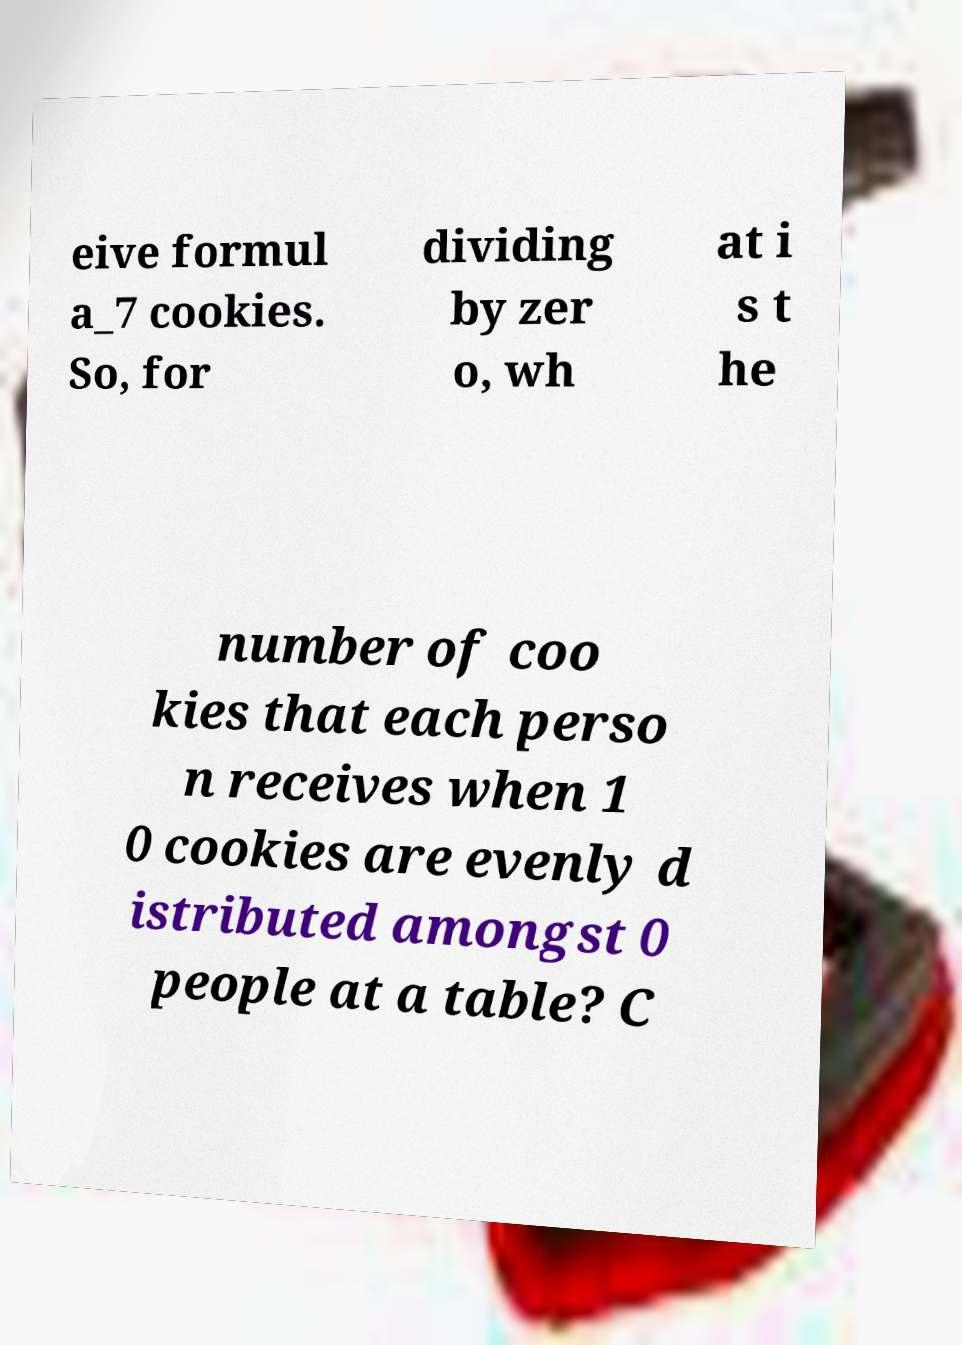There's text embedded in this image that I need extracted. Can you transcribe it verbatim? eive formul a_7 cookies. So, for dividing by zer o, wh at i s t he number of coo kies that each perso n receives when 1 0 cookies are evenly d istributed amongst 0 people at a table? C 